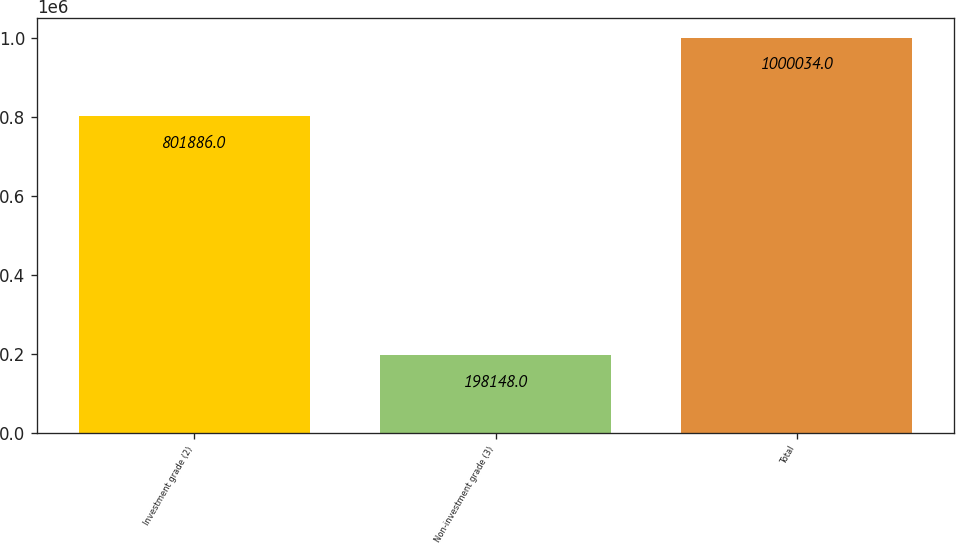Convert chart to OTSL. <chart><loc_0><loc_0><loc_500><loc_500><bar_chart><fcel>Investment grade (2)<fcel>Non-investment grade (3)<fcel>Total<nl><fcel>801886<fcel>198148<fcel>1.00003e+06<nl></chart> 